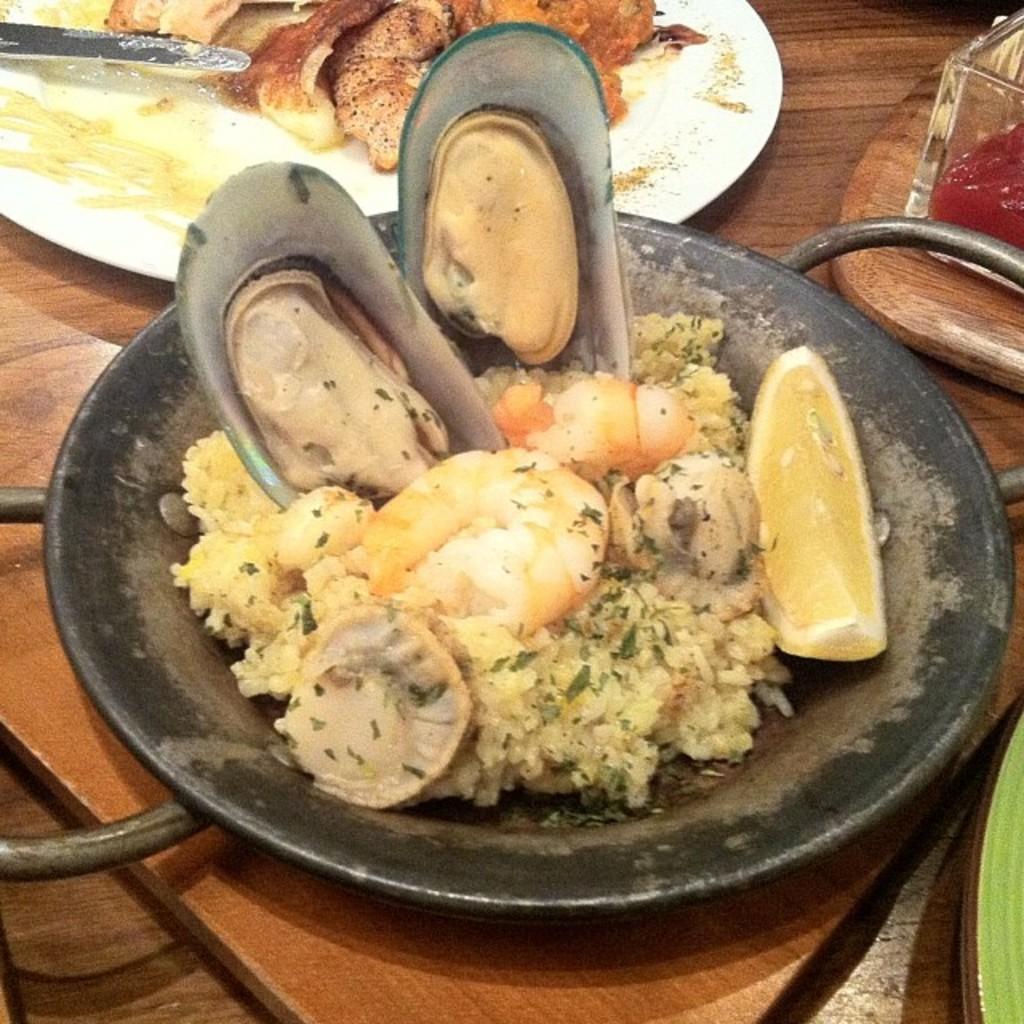In one or two sentences, can you explain what this image depicts? In this image, we can see a plate and dish on the table contains some food. 